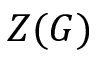<formula> <loc_0><loc_0><loc_500><loc_500>Z ( G )</formula> 